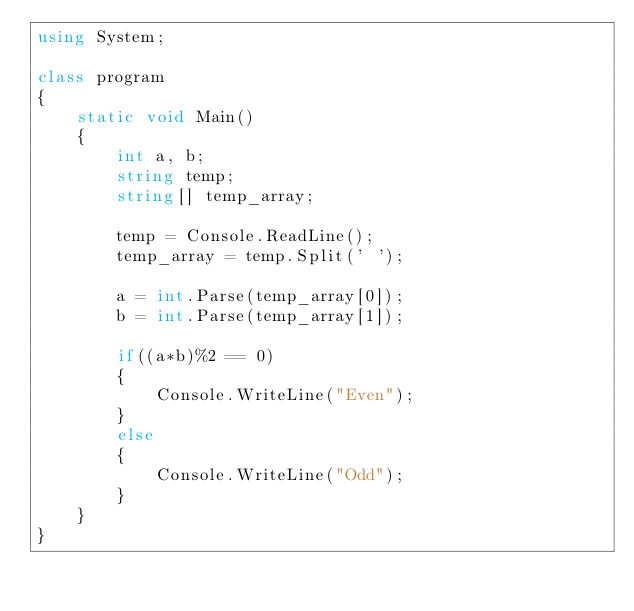<code> <loc_0><loc_0><loc_500><loc_500><_C#_>using System;

class program
{
    static void Main()
    {
        int a, b;
        string temp;
        string[] temp_array;

        temp = Console.ReadLine();
        temp_array = temp.Split(' ');

        a = int.Parse(temp_array[0]);
        b = int.Parse(temp_array[1]);

        if((a*b)%2 == 0)
        {
            Console.WriteLine("Even");
        }
        else
        {
            Console.WriteLine("Odd");
        }
    }
}

</code> 